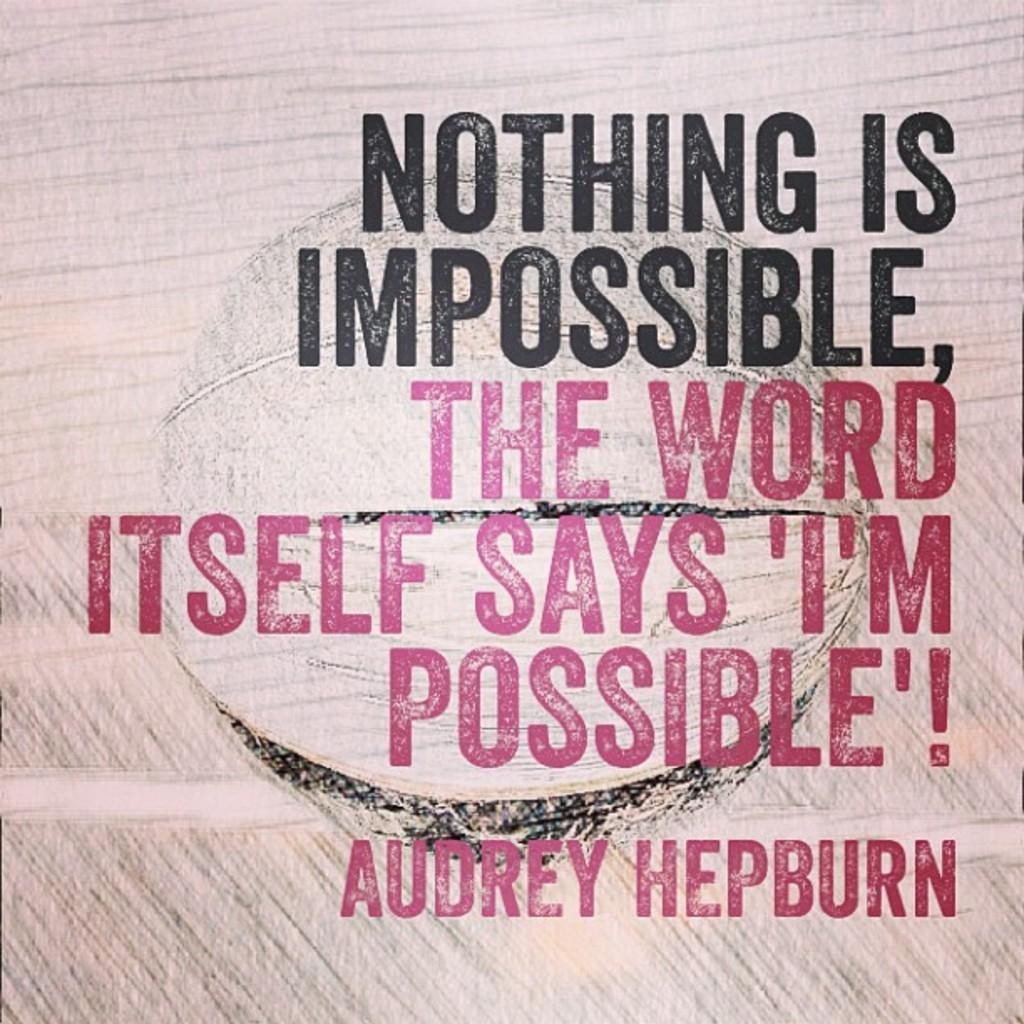What is present on the wall in the image? There is writing on the wall in the image. Can you describe the writing on the wall? Unfortunately, the specific content of the writing cannot be determined from the provided facts. What type of vegetable is being used as a mask in the image? There is no vegetable or mask present in the image; it only a wall with writing is visible. 